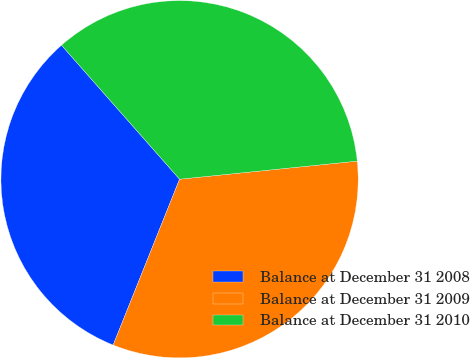<chart> <loc_0><loc_0><loc_500><loc_500><pie_chart><fcel>Balance at December 31 2008<fcel>Balance at December 31 2009<fcel>Balance at December 31 2010<nl><fcel>32.44%<fcel>32.68%<fcel>34.88%<nl></chart> 